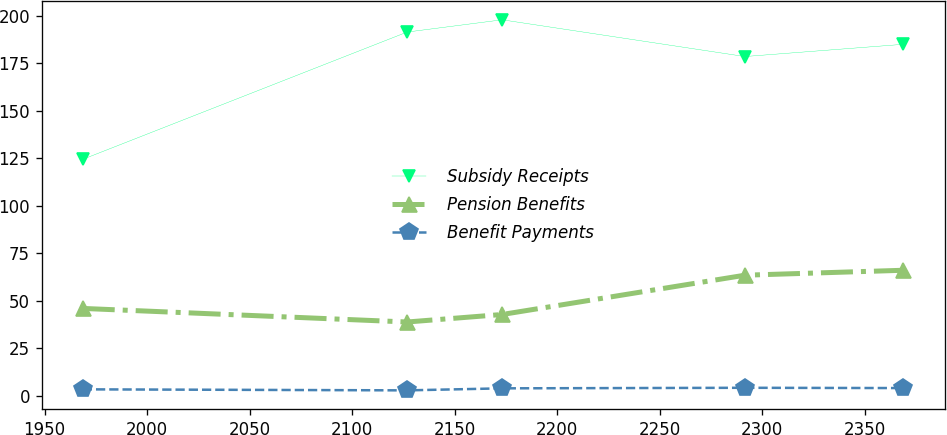Convert chart to OTSL. <chart><loc_0><loc_0><loc_500><loc_500><line_chart><ecel><fcel>Subsidy Receipts<fcel>Pension Benefits<fcel>Benefit Payments<nl><fcel>1968.64<fcel>124.45<fcel>45.94<fcel>3.32<nl><fcel>2126.84<fcel>191.5<fcel>38.79<fcel>2.78<nl><fcel>2173.18<fcel>197.95<fcel>42.75<fcel>3.85<nl><fcel>2291.5<fcel>178.6<fcel>63.43<fcel>4.14<nl><fcel>2368.85<fcel>185.05<fcel>66.04<fcel>3.99<nl></chart> 